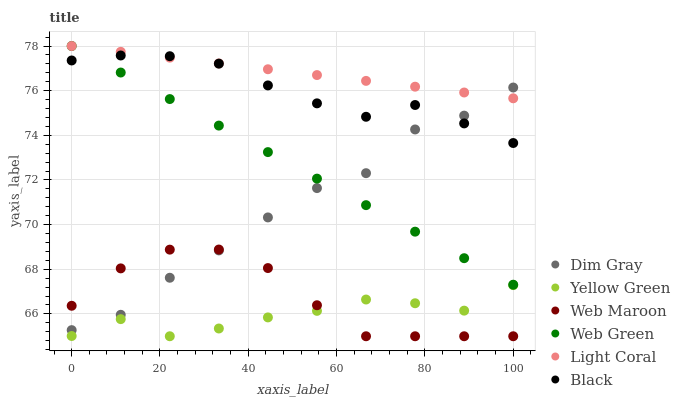Does Yellow Green have the minimum area under the curve?
Answer yes or no. Yes. Does Light Coral have the maximum area under the curve?
Answer yes or no. Yes. Does Web Maroon have the minimum area under the curve?
Answer yes or no. No. Does Web Maroon have the maximum area under the curve?
Answer yes or no. No. Is Light Coral the smoothest?
Answer yes or no. Yes. Is Dim Gray the roughest?
Answer yes or no. Yes. Is Yellow Green the smoothest?
Answer yes or no. No. Is Yellow Green the roughest?
Answer yes or no. No. Does Yellow Green have the lowest value?
Answer yes or no. Yes. Does Web Green have the lowest value?
Answer yes or no. No. Does Light Coral have the highest value?
Answer yes or no. Yes. Does Web Maroon have the highest value?
Answer yes or no. No. Is Yellow Green less than Light Coral?
Answer yes or no. Yes. Is Dim Gray greater than Yellow Green?
Answer yes or no. Yes. Does Dim Gray intersect Black?
Answer yes or no. Yes. Is Dim Gray less than Black?
Answer yes or no. No. Is Dim Gray greater than Black?
Answer yes or no. No. Does Yellow Green intersect Light Coral?
Answer yes or no. No. 